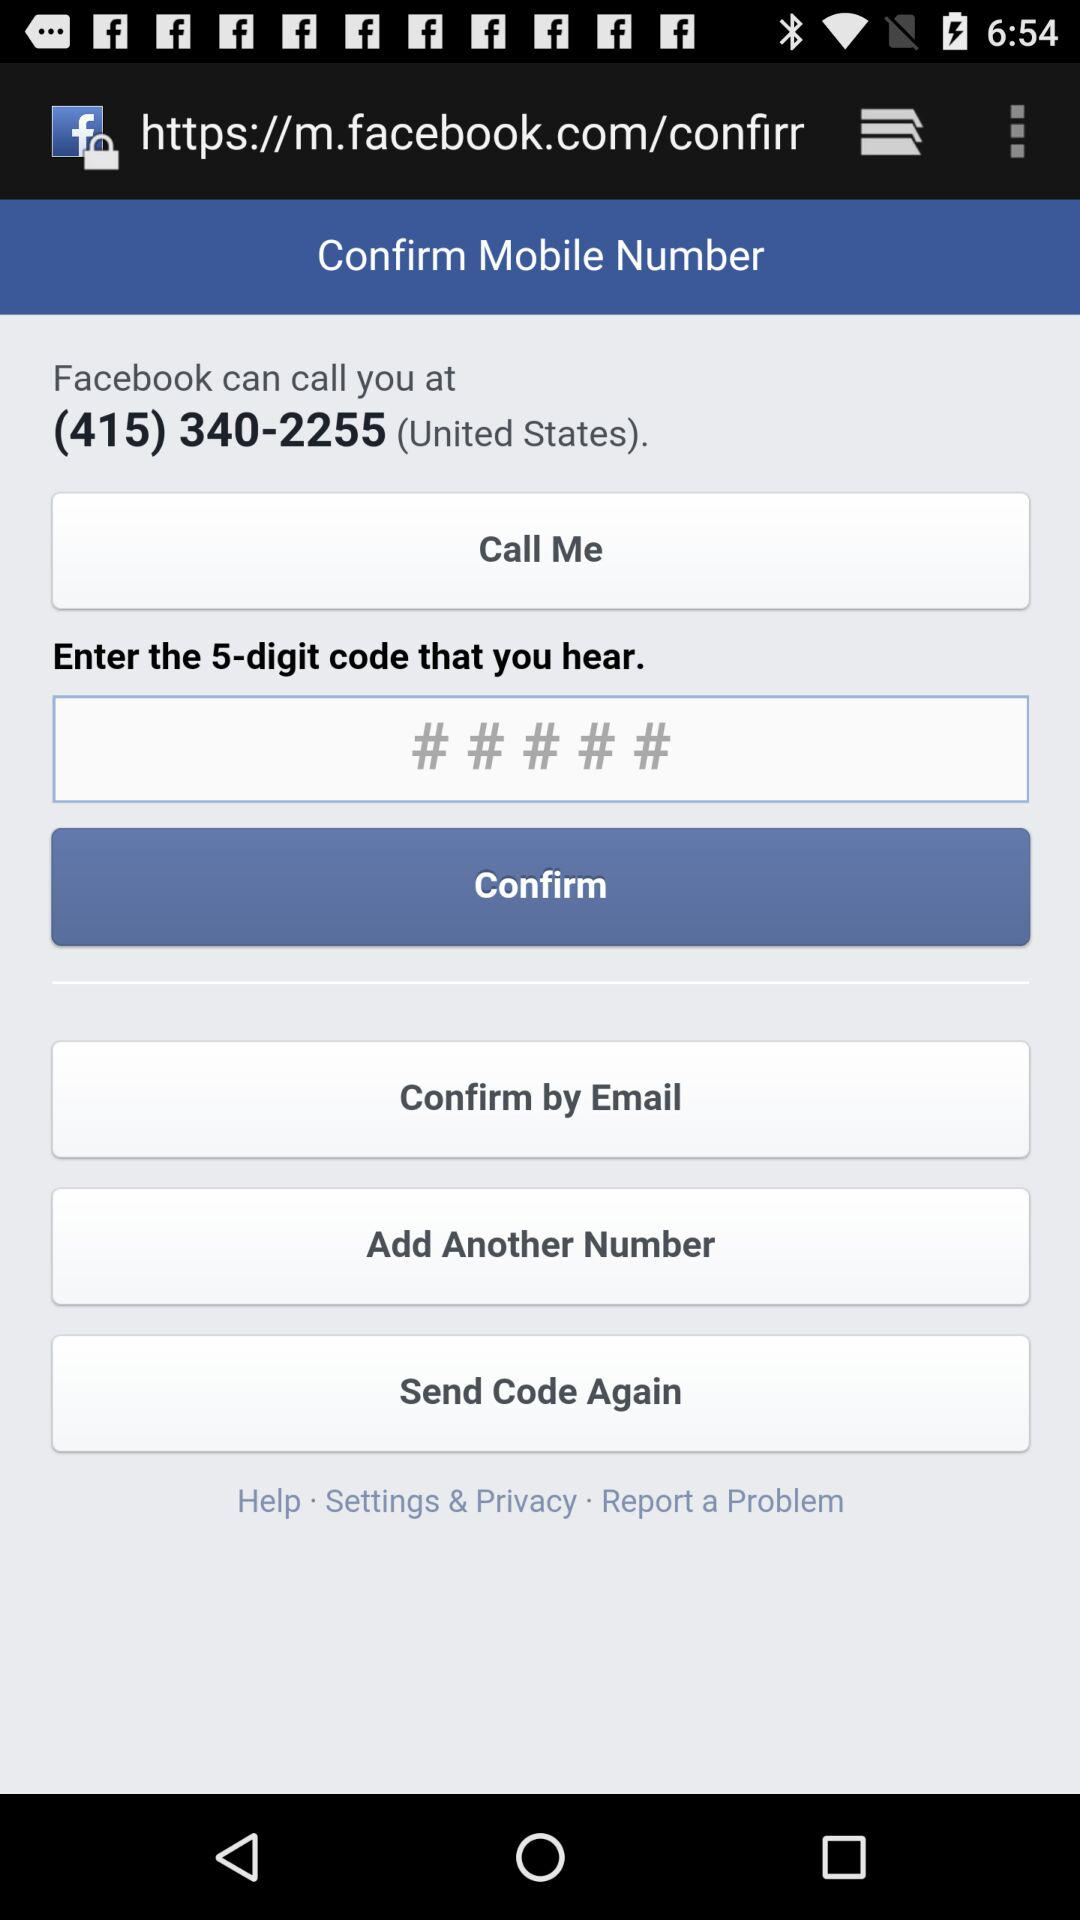How many ways can I confirm my mobile number?
Answer the question using a single word or phrase. 3 